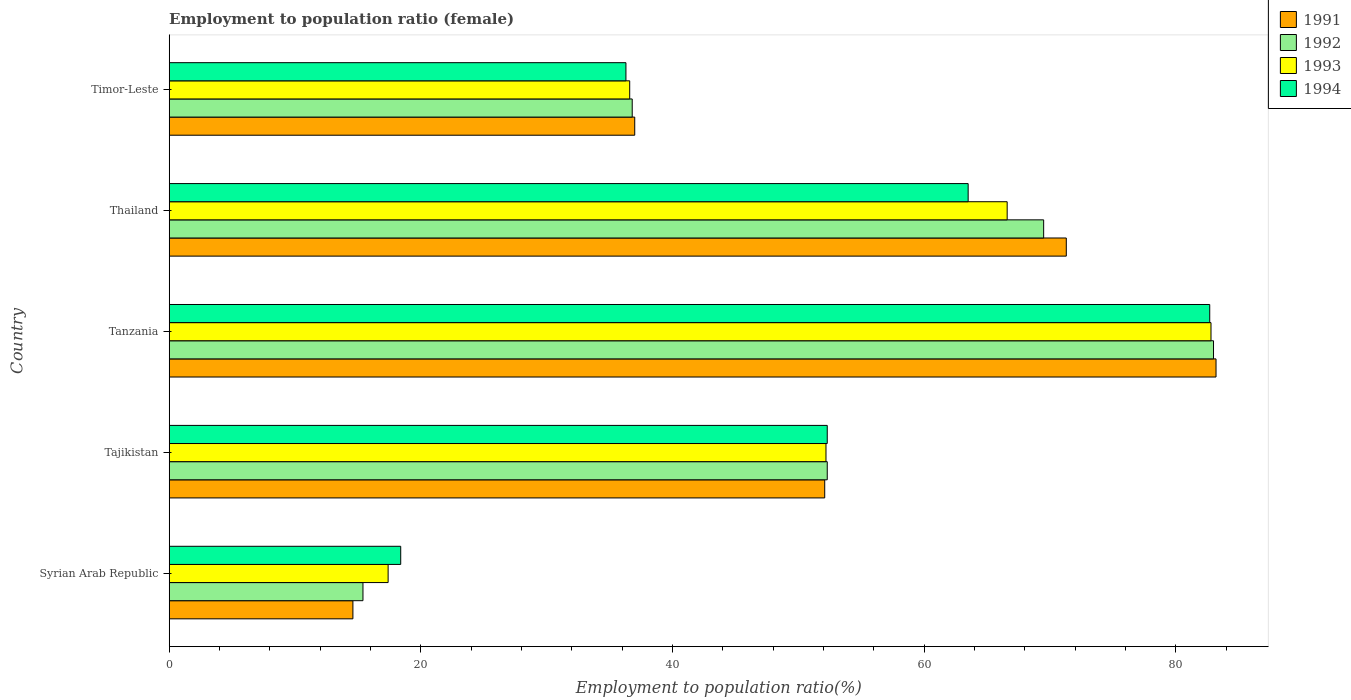How many different coloured bars are there?
Provide a succinct answer. 4. How many bars are there on the 2nd tick from the top?
Provide a succinct answer. 4. How many bars are there on the 4th tick from the bottom?
Offer a terse response. 4. What is the label of the 3rd group of bars from the top?
Your answer should be compact. Tanzania. In how many cases, is the number of bars for a given country not equal to the number of legend labels?
Offer a very short reply. 0. What is the employment to population ratio in 1994 in Tanzania?
Ensure brevity in your answer.  82.7. Across all countries, what is the maximum employment to population ratio in 1994?
Your answer should be compact. 82.7. Across all countries, what is the minimum employment to population ratio in 1993?
Keep it short and to the point. 17.4. In which country was the employment to population ratio in 1994 maximum?
Your answer should be very brief. Tanzania. In which country was the employment to population ratio in 1992 minimum?
Make the answer very short. Syrian Arab Republic. What is the total employment to population ratio in 1992 in the graph?
Your response must be concise. 257. What is the difference between the employment to population ratio in 1991 in Syrian Arab Republic and that in Thailand?
Offer a terse response. -56.7. What is the difference between the employment to population ratio in 1991 in Timor-Leste and the employment to population ratio in 1993 in Thailand?
Offer a very short reply. -29.6. What is the average employment to population ratio in 1991 per country?
Your answer should be compact. 51.64. What is the difference between the employment to population ratio in 1992 and employment to population ratio in 1993 in Tajikistan?
Keep it short and to the point. 0.1. What is the ratio of the employment to population ratio in 1992 in Syrian Arab Republic to that in Tajikistan?
Ensure brevity in your answer.  0.29. Is the difference between the employment to population ratio in 1992 in Tanzania and Timor-Leste greater than the difference between the employment to population ratio in 1993 in Tanzania and Timor-Leste?
Ensure brevity in your answer.  No. What is the difference between the highest and the second highest employment to population ratio in 1992?
Give a very brief answer. 13.5. What is the difference between the highest and the lowest employment to population ratio in 1993?
Offer a terse response. 65.4. Is it the case that in every country, the sum of the employment to population ratio in 1994 and employment to population ratio in 1992 is greater than the sum of employment to population ratio in 1991 and employment to population ratio in 1993?
Your answer should be compact. No. What does the 3rd bar from the bottom in Timor-Leste represents?
Give a very brief answer. 1993. Is it the case that in every country, the sum of the employment to population ratio in 1992 and employment to population ratio in 1994 is greater than the employment to population ratio in 1993?
Keep it short and to the point. Yes. How many bars are there?
Offer a very short reply. 20. Are all the bars in the graph horizontal?
Ensure brevity in your answer.  Yes. How many countries are there in the graph?
Provide a succinct answer. 5. Does the graph contain grids?
Give a very brief answer. No. What is the title of the graph?
Make the answer very short. Employment to population ratio (female). What is the Employment to population ratio(%) of 1991 in Syrian Arab Republic?
Your response must be concise. 14.6. What is the Employment to population ratio(%) of 1992 in Syrian Arab Republic?
Offer a terse response. 15.4. What is the Employment to population ratio(%) of 1993 in Syrian Arab Republic?
Make the answer very short. 17.4. What is the Employment to population ratio(%) in 1994 in Syrian Arab Republic?
Offer a terse response. 18.4. What is the Employment to population ratio(%) in 1991 in Tajikistan?
Give a very brief answer. 52.1. What is the Employment to population ratio(%) in 1992 in Tajikistan?
Offer a very short reply. 52.3. What is the Employment to population ratio(%) in 1993 in Tajikistan?
Offer a very short reply. 52.2. What is the Employment to population ratio(%) in 1994 in Tajikistan?
Provide a succinct answer. 52.3. What is the Employment to population ratio(%) of 1991 in Tanzania?
Provide a succinct answer. 83.2. What is the Employment to population ratio(%) in 1992 in Tanzania?
Offer a terse response. 83. What is the Employment to population ratio(%) in 1993 in Tanzania?
Give a very brief answer. 82.8. What is the Employment to population ratio(%) of 1994 in Tanzania?
Provide a succinct answer. 82.7. What is the Employment to population ratio(%) in 1991 in Thailand?
Give a very brief answer. 71.3. What is the Employment to population ratio(%) in 1992 in Thailand?
Give a very brief answer. 69.5. What is the Employment to population ratio(%) in 1993 in Thailand?
Your response must be concise. 66.6. What is the Employment to population ratio(%) in 1994 in Thailand?
Your answer should be very brief. 63.5. What is the Employment to population ratio(%) of 1992 in Timor-Leste?
Your response must be concise. 36.8. What is the Employment to population ratio(%) of 1993 in Timor-Leste?
Keep it short and to the point. 36.6. What is the Employment to population ratio(%) in 1994 in Timor-Leste?
Offer a very short reply. 36.3. Across all countries, what is the maximum Employment to population ratio(%) of 1991?
Give a very brief answer. 83.2. Across all countries, what is the maximum Employment to population ratio(%) of 1992?
Your answer should be very brief. 83. Across all countries, what is the maximum Employment to population ratio(%) of 1993?
Your response must be concise. 82.8. Across all countries, what is the maximum Employment to population ratio(%) in 1994?
Ensure brevity in your answer.  82.7. Across all countries, what is the minimum Employment to population ratio(%) of 1991?
Make the answer very short. 14.6. Across all countries, what is the minimum Employment to population ratio(%) of 1992?
Your answer should be compact. 15.4. Across all countries, what is the minimum Employment to population ratio(%) of 1993?
Make the answer very short. 17.4. Across all countries, what is the minimum Employment to population ratio(%) of 1994?
Make the answer very short. 18.4. What is the total Employment to population ratio(%) in 1991 in the graph?
Your answer should be very brief. 258.2. What is the total Employment to population ratio(%) of 1992 in the graph?
Offer a very short reply. 257. What is the total Employment to population ratio(%) in 1993 in the graph?
Your answer should be very brief. 255.6. What is the total Employment to population ratio(%) in 1994 in the graph?
Provide a succinct answer. 253.2. What is the difference between the Employment to population ratio(%) in 1991 in Syrian Arab Republic and that in Tajikistan?
Offer a terse response. -37.5. What is the difference between the Employment to population ratio(%) of 1992 in Syrian Arab Republic and that in Tajikistan?
Your response must be concise. -36.9. What is the difference between the Employment to population ratio(%) in 1993 in Syrian Arab Republic and that in Tajikistan?
Provide a short and direct response. -34.8. What is the difference between the Employment to population ratio(%) of 1994 in Syrian Arab Republic and that in Tajikistan?
Offer a very short reply. -33.9. What is the difference between the Employment to population ratio(%) in 1991 in Syrian Arab Republic and that in Tanzania?
Provide a short and direct response. -68.6. What is the difference between the Employment to population ratio(%) in 1992 in Syrian Arab Republic and that in Tanzania?
Your answer should be compact. -67.6. What is the difference between the Employment to population ratio(%) in 1993 in Syrian Arab Republic and that in Tanzania?
Provide a short and direct response. -65.4. What is the difference between the Employment to population ratio(%) in 1994 in Syrian Arab Republic and that in Tanzania?
Your answer should be compact. -64.3. What is the difference between the Employment to population ratio(%) in 1991 in Syrian Arab Republic and that in Thailand?
Offer a very short reply. -56.7. What is the difference between the Employment to population ratio(%) of 1992 in Syrian Arab Republic and that in Thailand?
Provide a succinct answer. -54.1. What is the difference between the Employment to population ratio(%) of 1993 in Syrian Arab Republic and that in Thailand?
Offer a very short reply. -49.2. What is the difference between the Employment to population ratio(%) in 1994 in Syrian Arab Republic and that in Thailand?
Your answer should be compact. -45.1. What is the difference between the Employment to population ratio(%) of 1991 in Syrian Arab Republic and that in Timor-Leste?
Give a very brief answer. -22.4. What is the difference between the Employment to population ratio(%) in 1992 in Syrian Arab Republic and that in Timor-Leste?
Your response must be concise. -21.4. What is the difference between the Employment to population ratio(%) of 1993 in Syrian Arab Republic and that in Timor-Leste?
Your answer should be compact. -19.2. What is the difference between the Employment to population ratio(%) in 1994 in Syrian Arab Republic and that in Timor-Leste?
Offer a terse response. -17.9. What is the difference between the Employment to population ratio(%) of 1991 in Tajikistan and that in Tanzania?
Your answer should be compact. -31.1. What is the difference between the Employment to population ratio(%) in 1992 in Tajikistan and that in Tanzania?
Provide a short and direct response. -30.7. What is the difference between the Employment to population ratio(%) of 1993 in Tajikistan and that in Tanzania?
Offer a very short reply. -30.6. What is the difference between the Employment to population ratio(%) of 1994 in Tajikistan and that in Tanzania?
Give a very brief answer. -30.4. What is the difference between the Employment to population ratio(%) in 1991 in Tajikistan and that in Thailand?
Give a very brief answer. -19.2. What is the difference between the Employment to population ratio(%) of 1992 in Tajikistan and that in Thailand?
Your answer should be compact. -17.2. What is the difference between the Employment to population ratio(%) of 1993 in Tajikistan and that in Thailand?
Offer a terse response. -14.4. What is the difference between the Employment to population ratio(%) in 1994 in Tajikistan and that in Thailand?
Keep it short and to the point. -11.2. What is the difference between the Employment to population ratio(%) of 1991 in Tajikistan and that in Timor-Leste?
Offer a terse response. 15.1. What is the difference between the Employment to population ratio(%) of 1991 in Tanzania and that in Thailand?
Keep it short and to the point. 11.9. What is the difference between the Employment to population ratio(%) of 1994 in Tanzania and that in Thailand?
Your answer should be very brief. 19.2. What is the difference between the Employment to population ratio(%) of 1991 in Tanzania and that in Timor-Leste?
Ensure brevity in your answer.  46.2. What is the difference between the Employment to population ratio(%) of 1992 in Tanzania and that in Timor-Leste?
Your answer should be very brief. 46.2. What is the difference between the Employment to population ratio(%) in 1993 in Tanzania and that in Timor-Leste?
Offer a very short reply. 46.2. What is the difference between the Employment to population ratio(%) in 1994 in Tanzania and that in Timor-Leste?
Offer a terse response. 46.4. What is the difference between the Employment to population ratio(%) in 1991 in Thailand and that in Timor-Leste?
Make the answer very short. 34.3. What is the difference between the Employment to population ratio(%) of 1992 in Thailand and that in Timor-Leste?
Offer a very short reply. 32.7. What is the difference between the Employment to population ratio(%) of 1993 in Thailand and that in Timor-Leste?
Offer a terse response. 30. What is the difference between the Employment to population ratio(%) in 1994 in Thailand and that in Timor-Leste?
Keep it short and to the point. 27.2. What is the difference between the Employment to population ratio(%) of 1991 in Syrian Arab Republic and the Employment to population ratio(%) of 1992 in Tajikistan?
Provide a succinct answer. -37.7. What is the difference between the Employment to population ratio(%) in 1991 in Syrian Arab Republic and the Employment to population ratio(%) in 1993 in Tajikistan?
Your answer should be compact. -37.6. What is the difference between the Employment to population ratio(%) in 1991 in Syrian Arab Republic and the Employment to population ratio(%) in 1994 in Tajikistan?
Provide a succinct answer. -37.7. What is the difference between the Employment to population ratio(%) of 1992 in Syrian Arab Republic and the Employment to population ratio(%) of 1993 in Tajikistan?
Your response must be concise. -36.8. What is the difference between the Employment to population ratio(%) in 1992 in Syrian Arab Republic and the Employment to population ratio(%) in 1994 in Tajikistan?
Your answer should be compact. -36.9. What is the difference between the Employment to population ratio(%) of 1993 in Syrian Arab Republic and the Employment to population ratio(%) of 1994 in Tajikistan?
Keep it short and to the point. -34.9. What is the difference between the Employment to population ratio(%) of 1991 in Syrian Arab Republic and the Employment to population ratio(%) of 1992 in Tanzania?
Provide a short and direct response. -68.4. What is the difference between the Employment to population ratio(%) of 1991 in Syrian Arab Republic and the Employment to population ratio(%) of 1993 in Tanzania?
Your answer should be compact. -68.2. What is the difference between the Employment to population ratio(%) in 1991 in Syrian Arab Republic and the Employment to population ratio(%) in 1994 in Tanzania?
Your response must be concise. -68.1. What is the difference between the Employment to population ratio(%) in 1992 in Syrian Arab Republic and the Employment to population ratio(%) in 1993 in Tanzania?
Give a very brief answer. -67.4. What is the difference between the Employment to population ratio(%) in 1992 in Syrian Arab Republic and the Employment to population ratio(%) in 1994 in Tanzania?
Make the answer very short. -67.3. What is the difference between the Employment to population ratio(%) of 1993 in Syrian Arab Republic and the Employment to population ratio(%) of 1994 in Tanzania?
Offer a terse response. -65.3. What is the difference between the Employment to population ratio(%) of 1991 in Syrian Arab Republic and the Employment to population ratio(%) of 1992 in Thailand?
Give a very brief answer. -54.9. What is the difference between the Employment to population ratio(%) in 1991 in Syrian Arab Republic and the Employment to population ratio(%) in 1993 in Thailand?
Provide a succinct answer. -52. What is the difference between the Employment to population ratio(%) of 1991 in Syrian Arab Republic and the Employment to population ratio(%) of 1994 in Thailand?
Your answer should be very brief. -48.9. What is the difference between the Employment to population ratio(%) in 1992 in Syrian Arab Republic and the Employment to population ratio(%) in 1993 in Thailand?
Provide a succinct answer. -51.2. What is the difference between the Employment to population ratio(%) in 1992 in Syrian Arab Republic and the Employment to population ratio(%) in 1994 in Thailand?
Provide a short and direct response. -48.1. What is the difference between the Employment to population ratio(%) of 1993 in Syrian Arab Republic and the Employment to population ratio(%) of 1994 in Thailand?
Your answer should be very brief. -46.1. What is the difference between the Employment to population ratio(%) of 1991 in Syrian Arab Republic and the Employment to population ratio(%) of 1992 in Timor-Leste?
Your answer should be very brief. -22.2. What is the difference between the Employment to population ratio(%) of 1991 in Syrian Arab Republic and the Employment to population ratio(%) of 1994 in Timor-Leste?
Your response must be concise. -21.7. What is the difference between the Employment to population ratio(%) in 1992 in Syrian Arab Republic and the Employment to population ratio(%) in 1993 in Timor-Leste?
Your answer should be very brief. -21.2. What is the difference between the Employment to population ratio(%) of 1992 in Syrian Arab Republic and the Employment to population ratio(%) of 1994 in Timor-Leste?
Give a very brief answer. -20.9. What is the difference between the Employment to population ratio(%) of 1993 in Syrian Arab Republic and the Employment to population ratio(%) of 1994 in Timor-Leste?
Your answer should be compact. -18.9. What is the difference between the Employment to population ratio(%) in 1991 in Tajikistan and the Employment to population ratio(%) in 1992 in Tanzania?
Provide a succinct answer. -30.9. What is the difference between the Employment to population ratio(%) of 1991 in Tajikistan and the Employment to population ratio(%) of 1993 in Tanzania?
Your response must be concise. -30.7. What is the difference between the Employment to population ratio(%) of 1991 in Tajikistan and the Employment to population ratio(%) of 1994 in Tanzania?
Provide a short and direct response. -30.6. What is the difference between the Employment to population ratio(%) of 1992 in Tajikistan and the Employment to population ratio(%) of 1993 in Tanzania?
Provide a succinct answer. -30.5. What is the difference between the Employment to population ratio(%) in 1992 in Tajikistan and the Employment to population ratio(%) in 1994 in Tanzania?
Keep it short and to the point. -30.4. What is the difference between the Employment to population ratio(%) of 1993 in Tajikistan and the Employment to population ratio(%) of 1994 in Tanzania?
Offer a very short reply. -30.5. What is the difference between the Employment to population ratio(%) of 1991 in Tajikistan and the Employment to population ratio(%) of 1992 in Thailand?
Keep it short and to the point. -17.4. What is the difference between the Employment to population ratio(%) in 1991 in Tajikistan and the Employment to population ratio(%) in 1994 in Thailand?
Ensure brevity in your answer.  -11.4. What is the difference between the Employment to population ratio(%) in 1992 in Tajikistan and the Employment to population ratio(%) in 1993 in Thailand?
Offer a very short reply. -14.3. What is the difference between the Employment to population ratio(%) of 1993 in Tajikistan and the Employment to population ratio(%) of 1994 in Thailand?
Make the answer very short. -11.3. What is the difference between the Employment to population ratio(%) in 1991 in Tajikistan and the Employment to population ratio(%) in 1992 in Timor-Leste?
Offer a terse response. 15.3. What is the difference between the Employment to population ratio(%) of 1991 in Tajikistan and the Employment to population ratio(%) of 1993 in Timor-Leste?
Provide a short and direct response. 15.5. What is the difference between the Employment to population ratio(%) of 1991 in Tajikistan and the Employment to population ratio(%) of 1994 in Timor-Leste?
Your answer should be compact. 15.8. What is the difference between the Employment to population ratio(%) of 1992 in Tajikistan and the Employment to population ratio(%) of 1993 in Timor-Leste?
Provide a short and direct response. 15.7. What is the difference between the Employment to population ratio(%) in 1991 in Tanzania and the Employment to population ratio(%) in 1992 in Thailand?
Provide a succinct answer. 13.7. What is the difference between the Employment to population ratio(%) in 1991 in Tanzania and the Employment to population ratio(%) in 1993 in Thailand?
Offer a terse response. 16.6. What is the difference between the Employment to population ratio(%) of 1992 in Tanzania and the Employment to population ratio(%) of 1994 in Thailand?
Your response must be concise. 19.5. What is the difference between the Employment to population ratio(%) of 1993 in Tanzania and the Employment to population ratio(%) of 1994 in Thailand?
Your response must be concise. 19.3. What is the difference between the Employment to population ratio(%) in 1991 in Tanzania and the Employment to population ratio(%) in 1992 in Timor-Leste?
Your response must be concise. 46.4. What is the difference between the Employment to population ratio(%) of 1991 in Tanzania and the Employment to population ratio(%) of 1993 in Timor-Leste?
Ensure brevity in your answer.  46.6. What is the difference between the Employment to population ratio(%) of 1991 in Tanzania and the Employment to population ratio(%) of 1994 in Timor-Leste?
Provide a short and direct response. 46.9. What is the difference between the Employment to population ratio(%) in 1992 in Tanzania and the Employment to population ratio(%) in 1993 in Timor-Leste?
Offer a very short reply. 46.4. What is the difference between the Employment to population ratio(%) of 1992 in Tanzania and the Employment to population ratio(%) of 1994 in Timor-Leste?
Offer a terse response. 46.7. What is the difference between the Employment to population ratio(%) of 1993 in Tanzania and the Employment to population ratio(%) of 1994 in Timor-Leste?
Give a very brief answer. 46.5. What is the difference between the Employment to population ratio(%) of 1991 in Thailand and the Employment to population ratio(%) of 1992 in Timor-Leste?
Give a very brief answer. 34.5. What is the difference between the Employment to population ratio(%) of 1991 in Thailand and the Employment to population ratio(%) of 1993 in Timor-Leste?
Provide a short and direct response. 34.7. What is the difference between the Employment to population ratio(%) of 1991 in Thailand and the Employment to population ratio(%) of 1994 in Timor-Leste?
Offer a very short reply. 35. What is the difference between the Employment to population ratio(%) in 1992 in Thailand and the Employment to population ratio(%) in 1993 in Timor-Leste?
Provide a succinct answer. 32.9. What is the difference between the Employment to population ratio(%) in 1992 in Thailand and the Employment to population ratio(%) in 1994 in Timor-Leste?
Keep it short and to the point. 33.2. What is the difference between the Employment to population ratio(%) of 1993 in Thailand and the Employment to population ratio(%) of 1994 in Timor-Leste?
Provide a succinct answer. 30.3. What is the average Employment to population ratio(%) of 1991 per country?
Keep it short and to the point. 51.64. What is the average Employment to population ratio(%) in 1992 per country?
Give a very brief answer. 51.4. What is the average Employment to population ratio(%) of 1993 per country?
Provide a short and direct response. 51.12. What is the average Employment to population ratio(%) of 1994 per country?
Offer a terse response. 50.64. What is the difference between the Employment to population ratio(%) of 1991 and Employment to population ratio(%) of 1992 in Syrian Arab Republic?
Offer a terse response. -0.8. What is the difference between the Employment to population ratio(%) of 1991 and Employment to population ratio(%) of 1993 in Syrian Arab Republic?
Ensure brevity in your answer.  -2.8. What is the difference between the Employment to population ratio(%) in 1992 and Employment to population ratio(%) in 1993 in Syrian Arab Republic?
Your answer should be compact. -2. What is the difference between the Employment to population ratio(%) in 1993 and Employment to population ratio(%) in 1994 in Syrian Arab Republic?
Give a very brief answer. -1. What is the difference between the Employment to population ratio(%) of 1991 and Employment to population ratio(%) of 1993 in Tajikistan?
Offer a very short reply. -0.1. What is the difference between the Employment to population ratio(%) of 1992 and Employment to population ratio(%) of 1993 in Tajikistan?
Your answer should be very brief. 0.1. What is the difference between the Employment to population ratio(%) in 1991 and Employment to population ratio(%) in 1992 in Tanzania?
Provide a short and direct response. 0.2. What is the difference between the Employment to population ratio(%) of 1991 and Employment to population ratio(%) of 1993 in Tanzania?
Your response must be concise. 0.4. What is the difference between the Employment to population ratio(%) of 1992 and Employment to population ratio(%) of 1994 in Tanzania?
Offer a very short reply. 0.3. What is the difference between the Employment to population ratio(%) in 1991 and Employment to population ratio(%) in 1992 in Thailand?
Ensure brevity in your answer.  1.8. What is the difference between the Employment to population ratio(%) of 1991 and Employment to population ratio(%) of 1994 in Thailand?
Keep it short and to the point. 7.8. What is the difference between the Employment to population ratio(%) in 1992 and Employment to population ratio(%) in 1993 in Thailand?
Offer a very short reply. 2.9. What is the difference between the Employment to population ratio(%) of 1992 and Employment to population ratio(%) of 1994 in Thailand?
Offer a very short reply. 6. What is the difference between the Employment to population ratio(%) of 1991 and Employment to population ratio(%) of 1992 in Timor-Leste?
Provide a short and direct response. 0.2. What is the difference between the Employment to population ratio(%) of 1991 and Employment to population ratio(%) of 1993 in Timor-Leste?
Provide a short and direct response. 0.4. What is the difference between the Employment to population ratio(%) in 1992 and Employment to population ratio(%) in 1993 in Timor-Leste?
Offer a terse response. 0.2. What is the difference between the Employment to population ratio(%) in 1993 and Employment to population ratio(%) in 1994 in Timor-Leste?
Your response must be concise. 0.3. What is the ratio of the Employment to population ratio(%) of 1991 in Syrian Arab Republic to that in Tajikistan?
Provide a short and direct response. 0.28. What is the ratio of the Employment to population ratio(%) in 1992 in Syrian Arab Republic to that in Tajikistan?
Give a very brief answer. 0.29. What is the ratio of the Employment to population ratio(%) in 1994 in Syrian Arab Republic to that in Tajikistan?
Give a very brief answer. 0.35. What is the ratio of the Employment to population ratio(%) in 1991 in Syrian Arab Republic to that in Tanzania?
Your response must be concise. 0.18. What is the ratio of the Employment to population ratio(%) of 1992 in Syrian Arab Republic to that in Tanzania?
Keep it short and to the point. 0.19. What is the ratio of the Employment to population ratio(%) of 1993 in Syrian Arab Republic to that in Tanzania?
Keep it short and to the point. 0.21. What is the ratio of the Employment to population ratio(%) of 1994 in Syrian Arab Republic to that in Tanzania?
Ensure brevity in your answer.  0.22. What is the ratio of the Employment to population ratio(%) of 1991 in Syrian Arab Republic to that in Thailand?
Make the answer very short. 0.2. What is the ratio of the Employment to population ratio(%) of 1992 in Syrian Arab Republic to that in Thailand?
Make the answer very short. 0.22. What is the ratio of the Employment to population ratio(%) in 1993 in Syrian Arab Republic to that in Thailand?
Give a very brief answer. 0.26. What is the ratio of the Employment to population ratio(%) in 1994 in Syrian Arab Republic to that in Thailand?
Your answer should be very brief. 0.29. What is the ratio of the Employment to population ratio(%) in 1991 in Syrian Arab Republic to that in Timor-Leste?
Offer a terse response. 0.39. What is the ratio of the Employment to population ratio(%) in 1992 in Syrian Arab Republic to that in Timor-Leste?
Offer a terse response. 0.42. What is the ratio of the Employment to population ratio(%) of 1993 in Syrian Arab Republic to that in Timor-Leste?
Ensure brevity in your answer.  0.48. What is the ratio of the Employment to population ratio(%) in 1994 in Syrian Arab Republic to that in Timor-Leste?
Provide a succinct answer. 0.51. What is the ratio of the Employment to population ratio(%) of 1991 in Tajikistan to that in Tanzania?
Your answer should be compact. 0.63. What is the ratio of the Employment to population ratio(%) in 1992 in Tajikistan to that in Tanzania?
Provide a succinct answer. 0.63. What is the ratio of the Employment to population ratio(%) of 1993 in Tajikistan to that in Tanzania?
Provide a short and direct response. 0.63. What is the ratio of the Employment to population ratio(%) in 1994 in Tajikistan to that in Tanzania?
Ensure brevity in your answer.  0.63. What is the ratio of the Employment to population ratio(%) in 1991 in Tajikistan to that in Thailand?
Your answer should be very brief. 0.73. What is the ratio of the Employment to population ratio(%) in 1992 in Tajikistan to that in Thailand?
Offer a very short reply. 0.75. What is the ratio of the Employment to population ratio(%) in 1993 in Tajikistan to that in Thailand?
Give a very brief answer. 0.78. What is the ratio of the Employment to population ratio(%) in 1994 in Tajikistan to that in Thailand?
Your answer should be compact. 0.82. What is the ratio of the Employment to population ratio(%) in 1991 in Tajikistan to that in Timor-Leste?
Offer a very short reply. 1.41. What is the ratio of the Employment to population ratio(%) of 1992 in Tajikistan to that in Timor-Leste?
Ensure brevity in your answer.  1.42. What is the ratio of the Employment to population ratio(%) of 1993 in Tajikistan to that in Timor-Leste?
Provide a short and direct response. 1.43. What is the ratio of the Employment to population ratio(%) in 1994 in Tajikistan to that in Timor-Leste?
Your answer should be compact. 1.44. What is the ratio of the Employment to population ratio(%) in 1991 in Tanzania to that in Thailand?
Provide a succinct answer. 1.17. What is the ratio of the Employment to population ratio(%) of 1992 in Tanzania to that in Thailand?
Ensure brevity in your answer.  1.19. What is the ratio of the Employment to population ratio(%) in 1993 in Tanzania to that in Thailand?
Your answer should be compact. 1.24. What is the ratio of the Employment to population ratio(%) of 1994 in Tanzania to that in Thailand?
Ensure brevity in your answer.  1.3. What is the ratio of the Employment to population ratio(%) of 1991 in Tanzania to that in Timor-Leste?
Make the answer very short. 2.25. What is the ratio of the Employment to population ratio(%) of 1992 in Tanzania to that in Timor-Leste?
Your answer should be compact. 2.26. What is the ratio of the Employment to population ratio(%) of 1993 in Tanzania to that in Timor-Leste?
Provide a succinct answer. 2.26. What is the ratio of the Employment to population ratio(%) of 1994 in Tanzania to that in Timor-Leste?
Make the answer very short. 2.28. What is the ratio of the Employment to population ratio(%) in 1991 in Thailand to that in Timor-Leste?
Your answer should be very brief. 1.93. What is the ratio of the Employment to population ratio(%) in 1992 in Thailand to that in Timor-Leste?
Make the answer very short. 1.89. What is the ratio of the Employment to population ratio(%) of 1993 in Thailand to that in Timor-Leste?
Keep it short and to the point. 1.82. What is the ratio of the Employment to population ratio(%) in 1994 in Thailand to that in Timor-Leste?
Your response must be concise. 1.75. What is the difference between the highest and the second highest Employment to population ratio(%) in 1992?
Your response must be concise. 13.5. What is the difference between the highest and the second highest Employment to population ratio(%) in 1993?
Provide a short and direct response. 16.2. What is the difference between the highest and the second highest Employment to population ratio(%) in 1994?
Your response must be concise. 19.2. What is the difference between the highest and the lowest Employment to population ratio(%) in 1991?
Ensure brevity in your answer.  68.6. What is the difference between the highest and the lowest Employment to population ratio(%) in 1992?
Make the answer very short. 67.6. What is the difference between the highest and the lowest Employment to population ratio(%) of 1993?
Offer a terse response. 65.4. What is the difference between the highest and the lowest Employment to population ratio(%) of 1994?
Offer a very short reply. 64.3. 